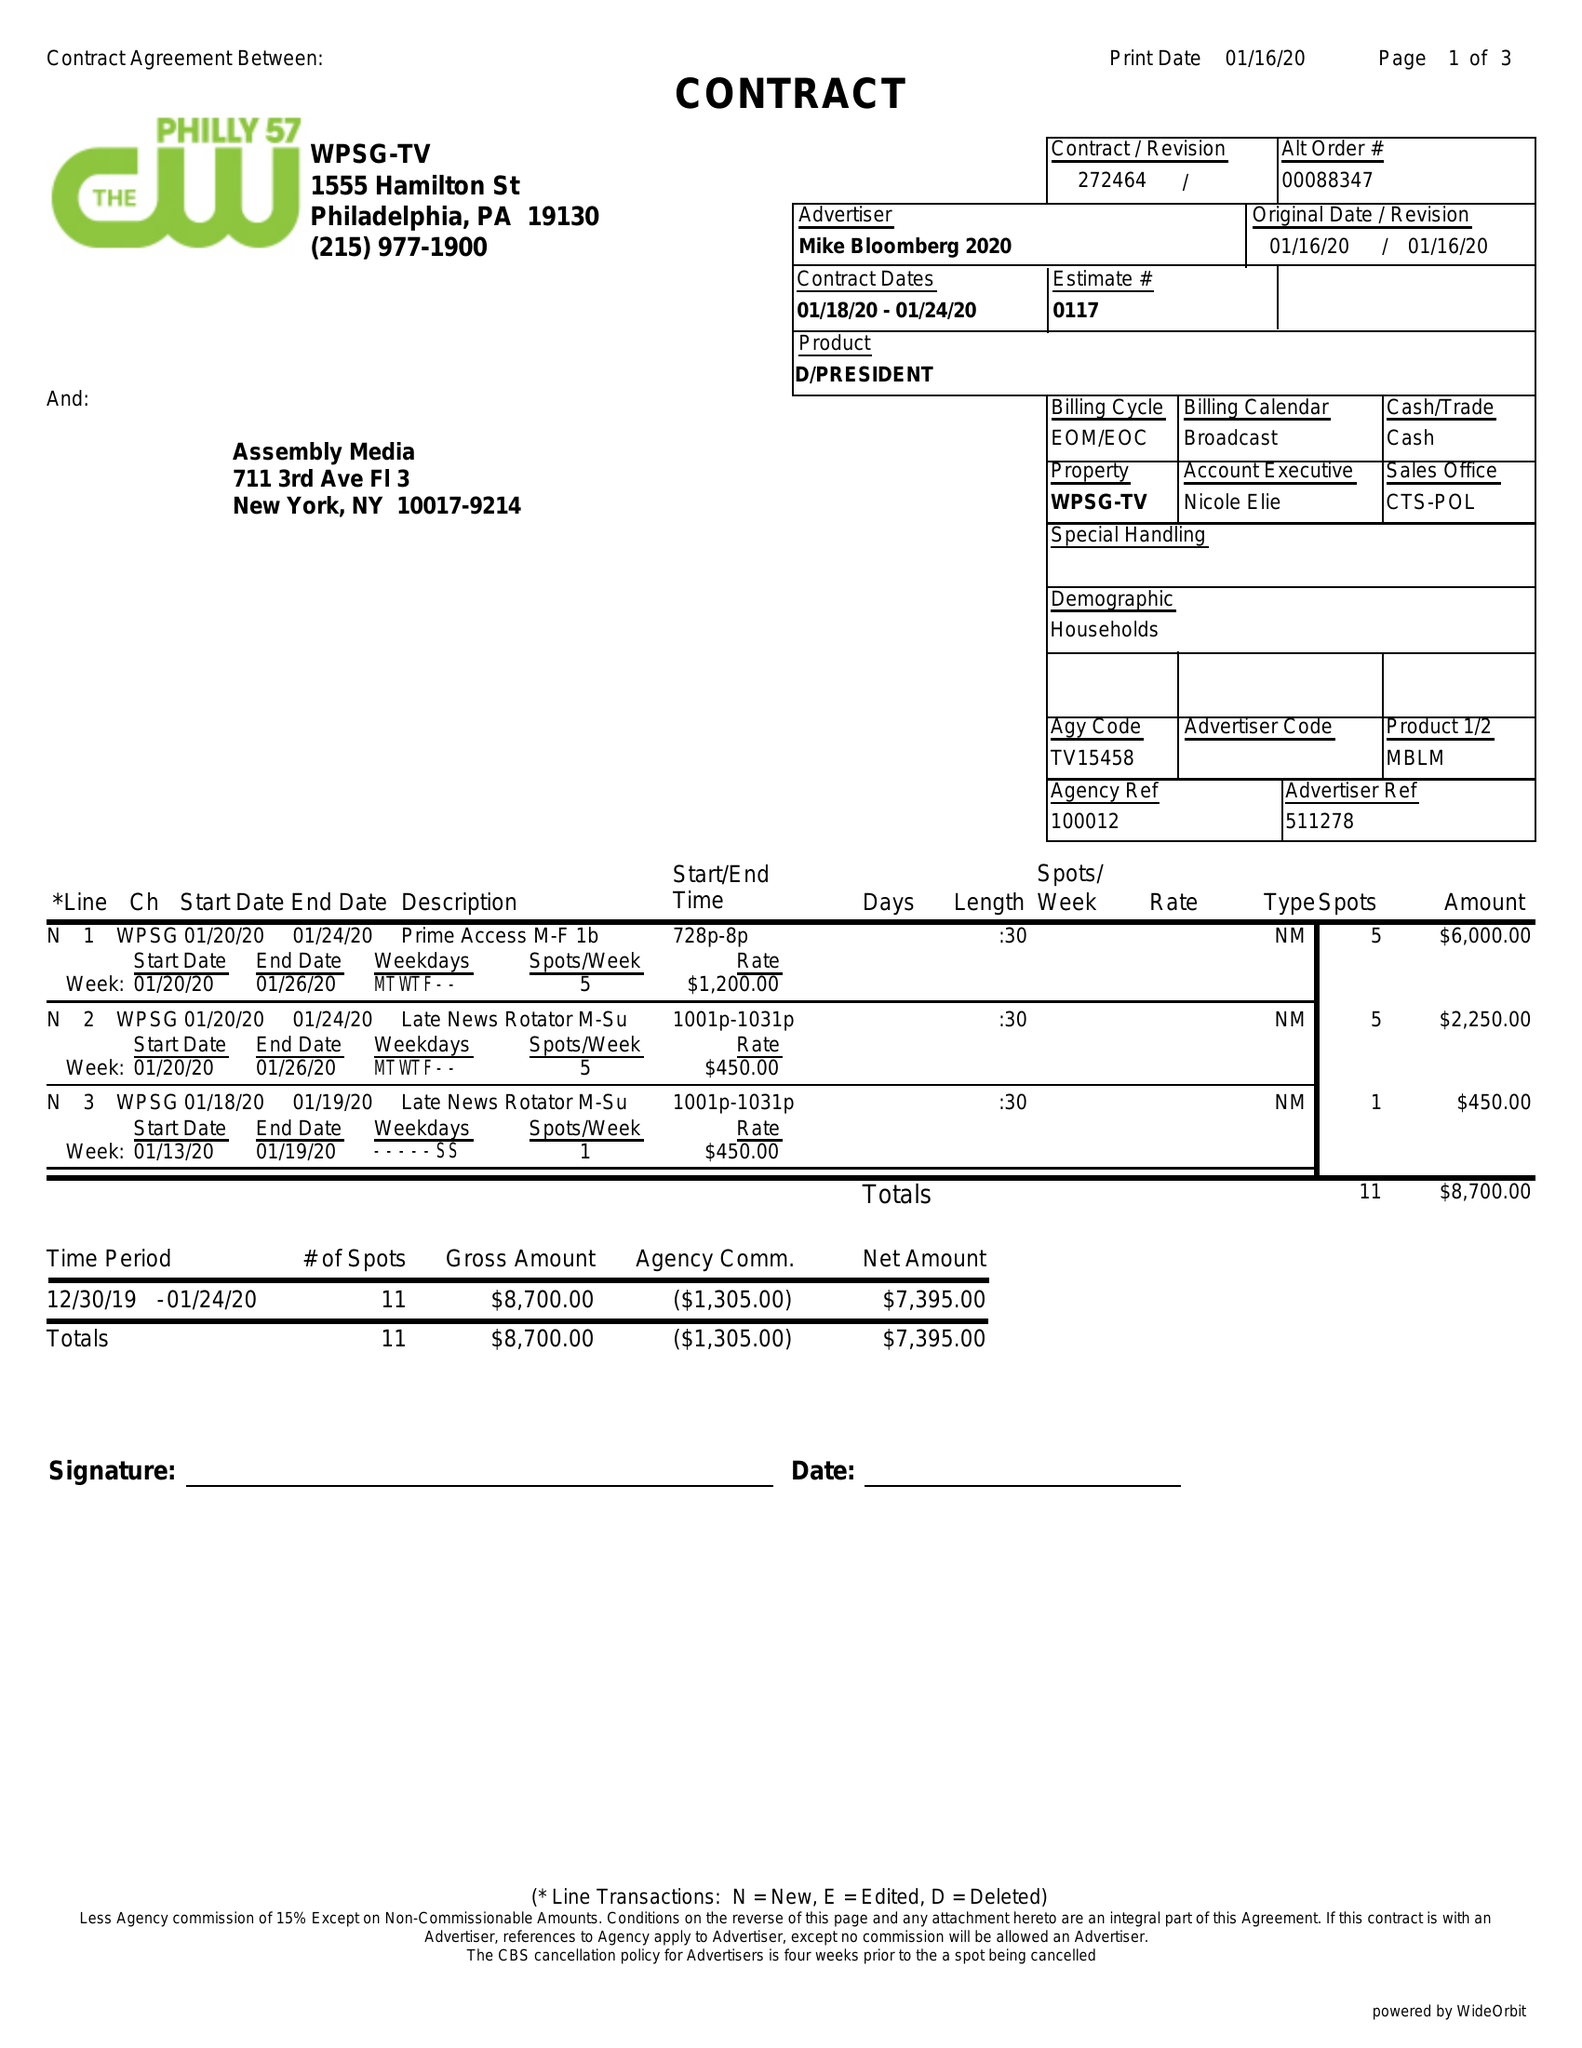What is the value for the contract_num?
Answer the question using a single word or phrase. 272464 